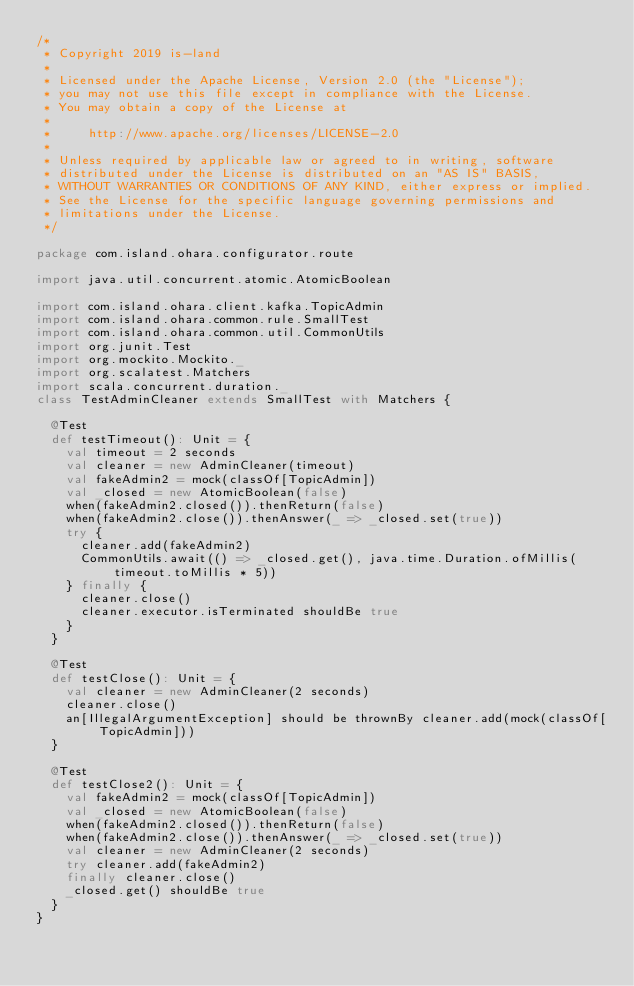<code> <loc_0><loc_0><loc_500><loc_500><_Scala_>/*
 * Copyright 2019 is-land
 *
 * Licensed under the Apache License, Version 2.0 (the "License");
 * you may not use this file except in compliance with the License.
 * You may obtain a copy of the License at
 *
 *     http://www.apache.org/licenses/LICENSE-2.0
 *
 * Unless required by applicable law or agreed to in writing, software
 * distributed under the License is distributed on an "AS IS" BASIS,
 * WITHOUT WARRANTIES OR CONDITIONS OF ANY KIND, either express or implied.
 * See the License for the specific language governing permissions and
 * limitations under the License.
 */

package com.island.ohara.configurator.route

import java.util.concurrent.atomic.AtomicBoolean

import com.island.ohara.client.kafka.TopicAdmin
import com.island.ohara.common.rule.SmallTest
import com.island.ohara.common.util.CommonUtils
import org.junit.Test
import org.mockito.Mockito._
import org.scalatest.Matchers
import scala.concurrent.duration._
class TestAdminCleaner extends SmallTest with Matchers {

  @Test
  def testTimeout(): Unit = {
    val timeout = 2 seconds
    val cleaner = new AdminCleaner(timeout)
    val fakeAdmin2 = mock(classOf[TopicAdmin])
    val _closed = new AtomicBoolean(false)
    when(fakeAdmin2.closed()).thenReturn(false)
    when(fakeAdmin2.close()).thenAnswer(_ => _closed.set(true))
    try {
      cleaner.add(fakeAdmin2)
      CommonUtils.await(() => _closed.get(), java.time.Duration.ofMillis(timeout.toMillis * 5))
    } finally {
      cleaner.close()
      cleaner.executor.isTerminated shouldBe true
    }
  }

  @Test
  def testClose(): Unit = {
    val cleaner = new AdminCleaner(2 seconds)
    cleaner.close()
    an[IllegalArgumentException] should be thrownBy cleaner.add(mock(classOf[TopicAdmin]))
  }

  @Test
  def testClose2(): Unit = {
    val fakeAdmin2 = mock(classOf[TopicAdmin])
    val _closed = new AtomicBoolean(false)
    when(fakeAdmin2.closed()).thenReturn(false)
    when(fakeAdmin2.close()).thenAnswer(_ => _closed.set(true))
    val cleaner = new AdminCleaner(2 seconds)
    try cleaner.add(fakeAdmin2)
    finally cleaner.close()
    _closed.get() shouldBe true
  }
}
</code> 